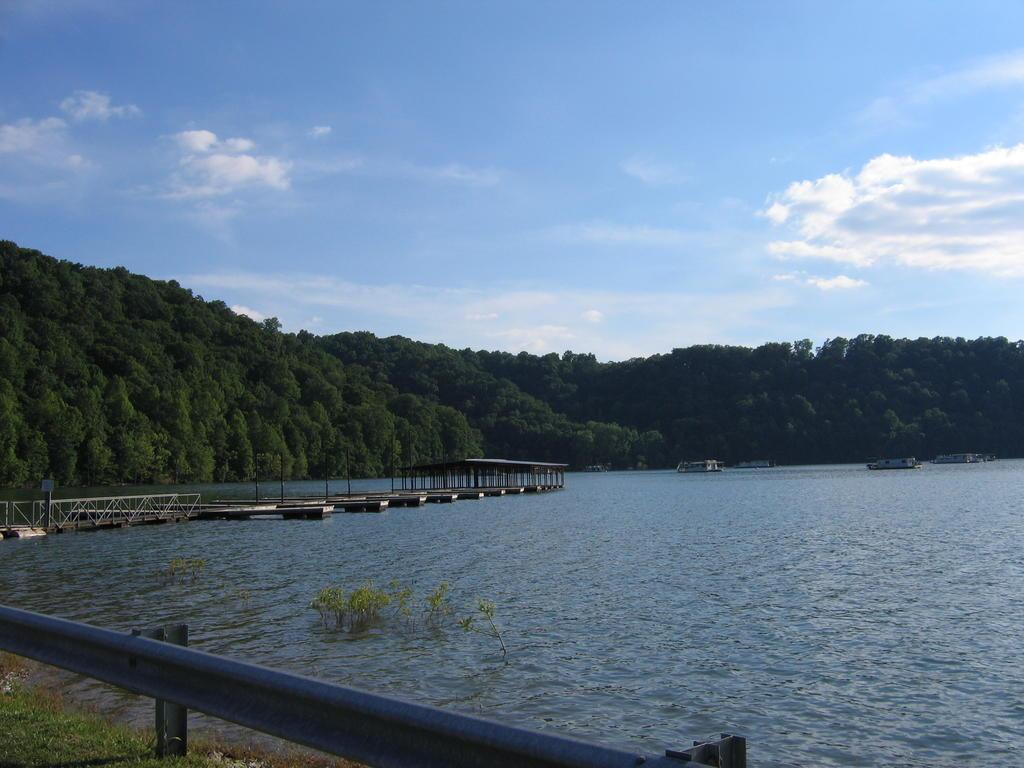What is happening in the water in the image? There are ships sailing in the water in the image. What structure can be seen crossing the water? There is a bridge across the water in the image. What type of vegetation is visible in the image? There are green trees visible in the image. What is visible above the water and trees? The sky is visible in the image, and clouds are present in the sky. Reasoning: Let's think step by step by step in order to produce the conversation. We start by identifying the main subjects and objects in the image based on the provided facts. We then formulate questions that focus on the location and characteristics of these subjects and objects, ensuring that each question can be answered definitively with the information given. We avoid yes/no questions and ensure that the language is simple and clear. Absurd Question/Answer: Can you see any horses running in the field in the image? There is no field or horses present in the image. How does the earthquake affect the ships sailing in the water in the image? There is no earthquake present in the image, so it does not affect the ships sailing in the water. 